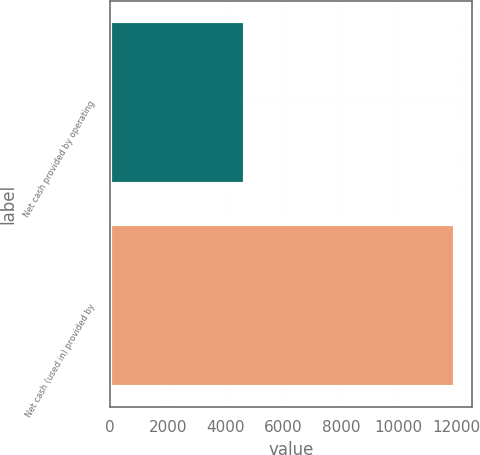<chart> <loc_0><loc_0><loc_500><loc_500><bar_chart><fcel>Net cash provided by operating<fcel>Net cash (used in) provided by<nl><fcel>4684<fcel>11954<nl></chart> 